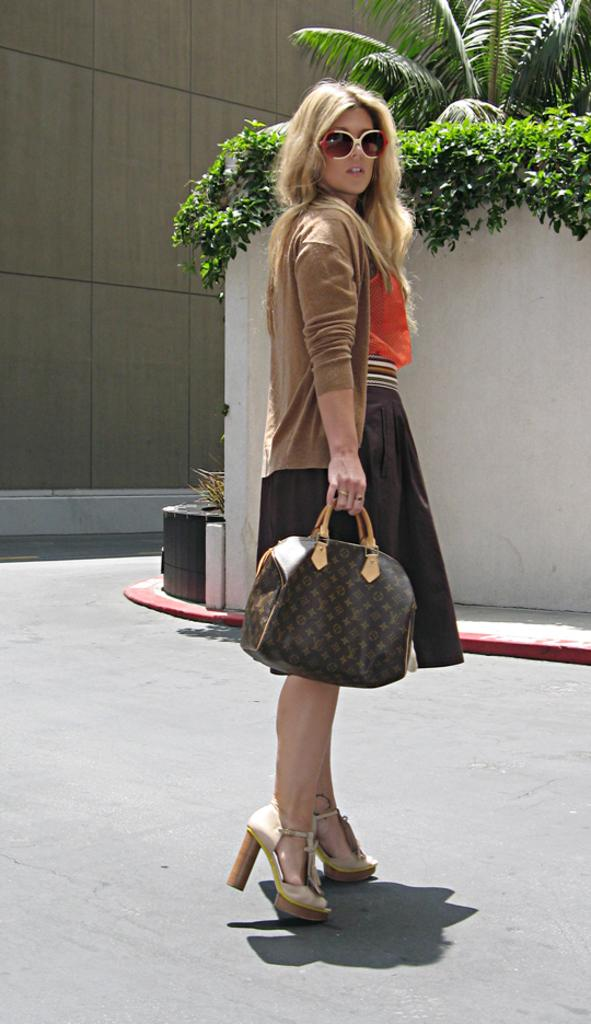Who is present in the image? There is a lady in the image. What is the lady doing in the image? The lady is standing on the road. What is the lady holding in her hands? The lady is holding a bag in her hands. What can be seen in the background of the image? There are trees, a wall, and a building in the background of the image. What type of rail is the lady using to cross the road in the image? There is no rail present in the image, and the lady is standing on the road, not crossing it. 